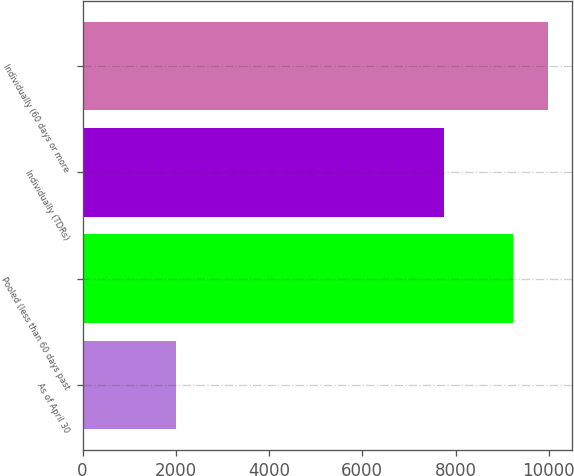<chart> <loc_0><loc_0><loc_500><loc_500><bar_chart><fcel>As of April 30<fcel>Pooled (less than 60 days past<fcel>Individually (TDRs)<fcel>Individually (60 days or more<nl><fcel>2012<fcel>9237<fcel>7752<fcel>9990.9<nl></chart> 